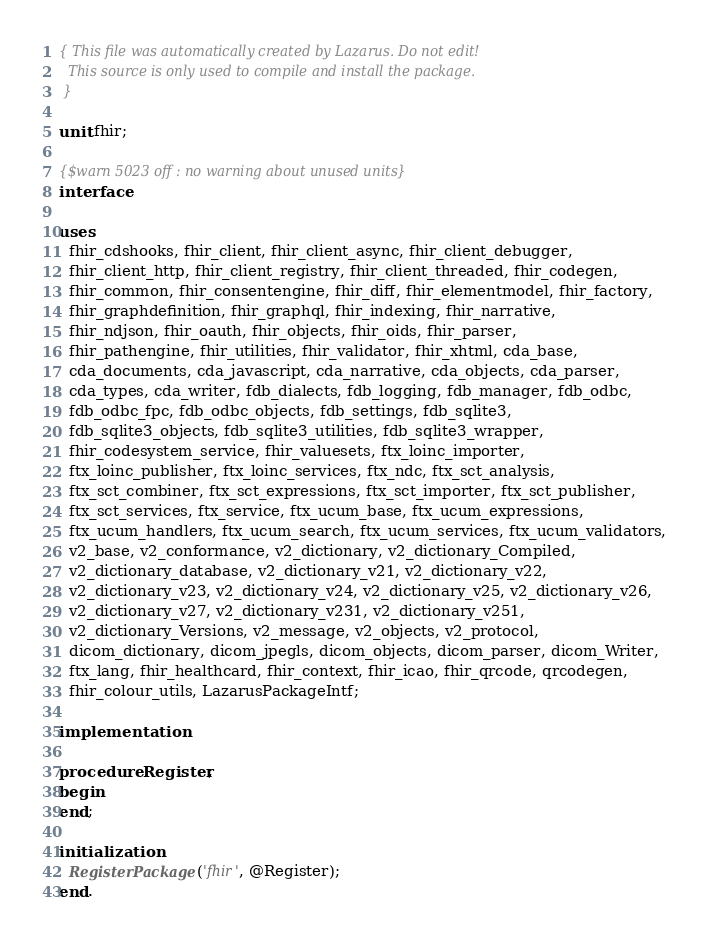<code> <loc_0><loc_0><loc_500><loc_500><_Pascal_>{ This file was automatically created by Lazarus. Do not edit!
  This source is only used to compile and install the package.
 }

unit fhir;

{$warn 5023 off : no warning about unused units}
interface

uses
  fhir_cdshooks, fhir_client, fhir_client_async, fhir_client_debugger, 
  fhir_client_http, fhir_client_registry, fhir_client_threaded, fhir_codegen, 
  fhir_common, fhir_consentengine, fhir_diff, fhir_elementmodel, fhir_factory, 
  fhir_graphdefinition, fhir_graphql, fhir_indexing, fhir_narrative, 
  fhir_ndjson, fhir_oauth, fhir_objects, fhir_oids, fhir_parser, 
  fhir_pathengine, fhir_utilities, fhir_validator, fhir_xhtml, cda_base, 
  cda_documents, cda_javascript, cda_narrative, cda_objects, cda_parser, 
  cda_types, cda_writer, fdb_dialects, fdb_logging, fdb_manager, fdb_odbc, 
  fdb_odbc_fpc, fdb_odbc_objects, fdb_settings, fdb_sqlite3, 
  fdb_sqlite3_objects, fdb_sqlite3_utilities, fdb_sqlite3_wrapper, 
  fhir_codesystem_service, fhir_valuesets, ftx_loinc_importer, 
  ftx_loinc_publisher, ftx_loinc_services, ftx_ndc, ftx_sct_analysis, 
  ftx_sct_combiner, ftx_sct_expressions, ftx_sct_importer, ftx_sct_publisher, 
  ftx_sct_services, ftx_service, ftx_ucum_base, ftx_ucum_expressions, 
  ftx_ucum_handlers, ftx_ucum_search, ftx_ucum_services, ftx_ucum_validators, 
  v2_base, v2_conformance, v2_dictionary, v2_dictionary_Compiled, 
  v2_dictionary_database, v2_dictionary_v21, v2_dictionary_v22, 
  v2_dictionary_v23, v2_dictionary_v24, v2_dictionary_v25, v2_dictionary_v26, 
  v2_dictionary_v27, v2_dictionary_v231, v2_dictionary_v251, 
  v2_dictionary_Versions, v2_message, v2_objects, v2_protocol, 
  dicom_dictionary, dicom_jpegls, dicom_objects, dicom_parser, dicom_Writer, 
  ftx_lang, fhir_healthcard, fhir_context, fhir_icao, fhir_qrcode, qrcodegen, 
  fhir_colour_utils, LazarusPackageIntf;

implementation

procedure Register;
begin
end;

initialization
  RegisterPackage('fhir', @Register);
end.
</code> 